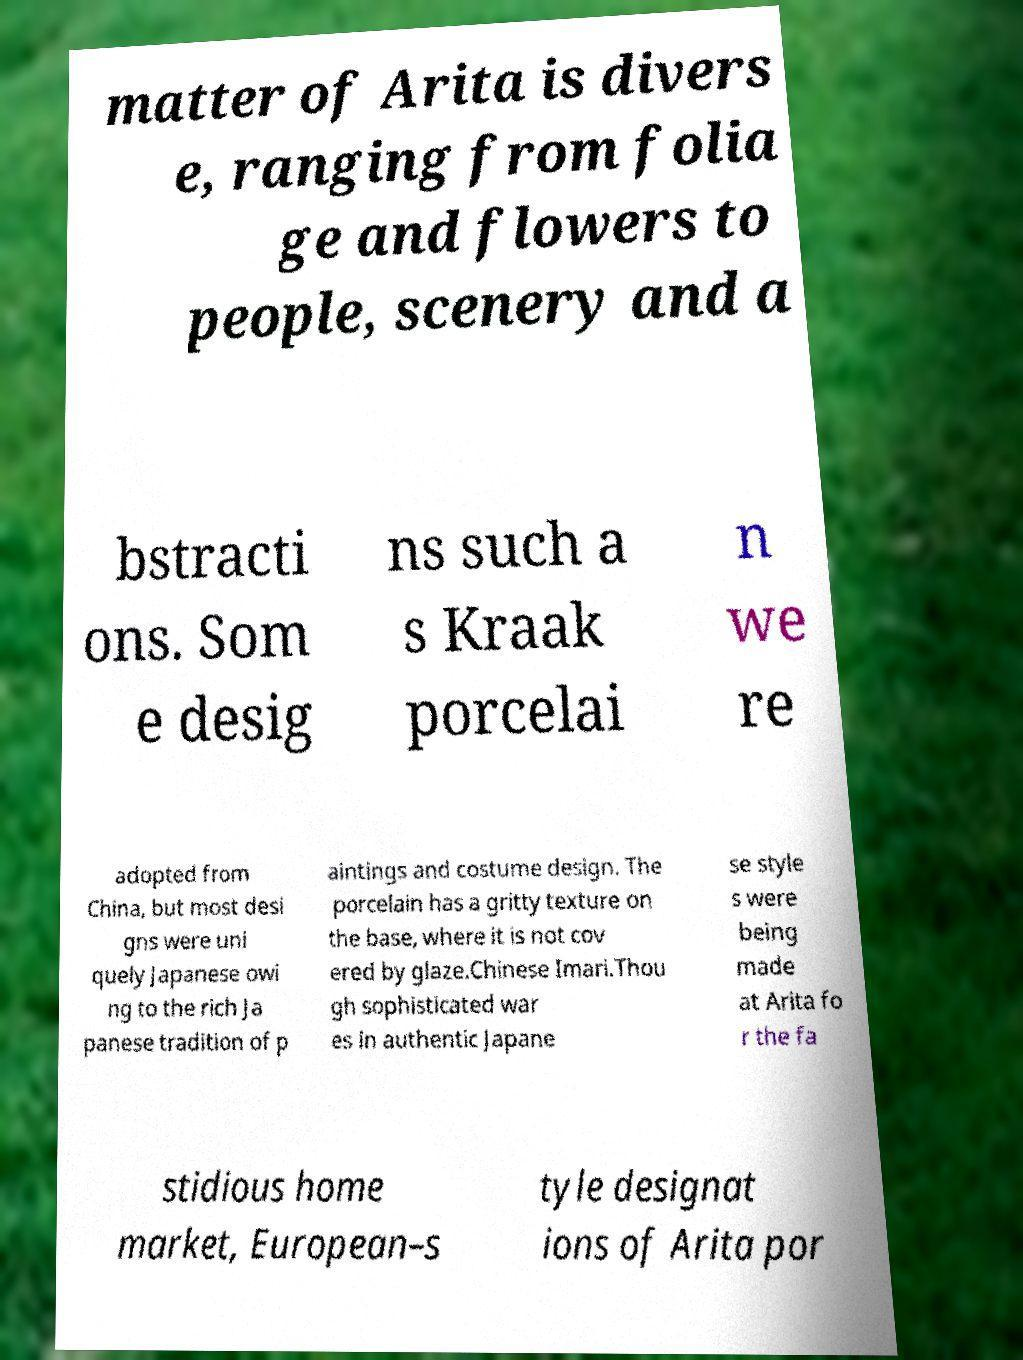Can you accurately transcribe the text from the provided image for me? matter of Arita is divers e, ranging from folia ge and flowers to people, scenery and a bstracti ons. Som e desig ns such a s Kraak porcelai n we re adopted from China, but most desi gns were uni quely Japanese owi ng to the rich Ja panese tradition of p aintings and costume design. The porcelain has a gritty texture on the base, where it is not cov ered by glaze.Chinese Imari.Thou gh sophisticated war es in authentic Japane se style s were being made at Arita fo r the fa stidious home market, European–s tyle designat ions of Arita por 